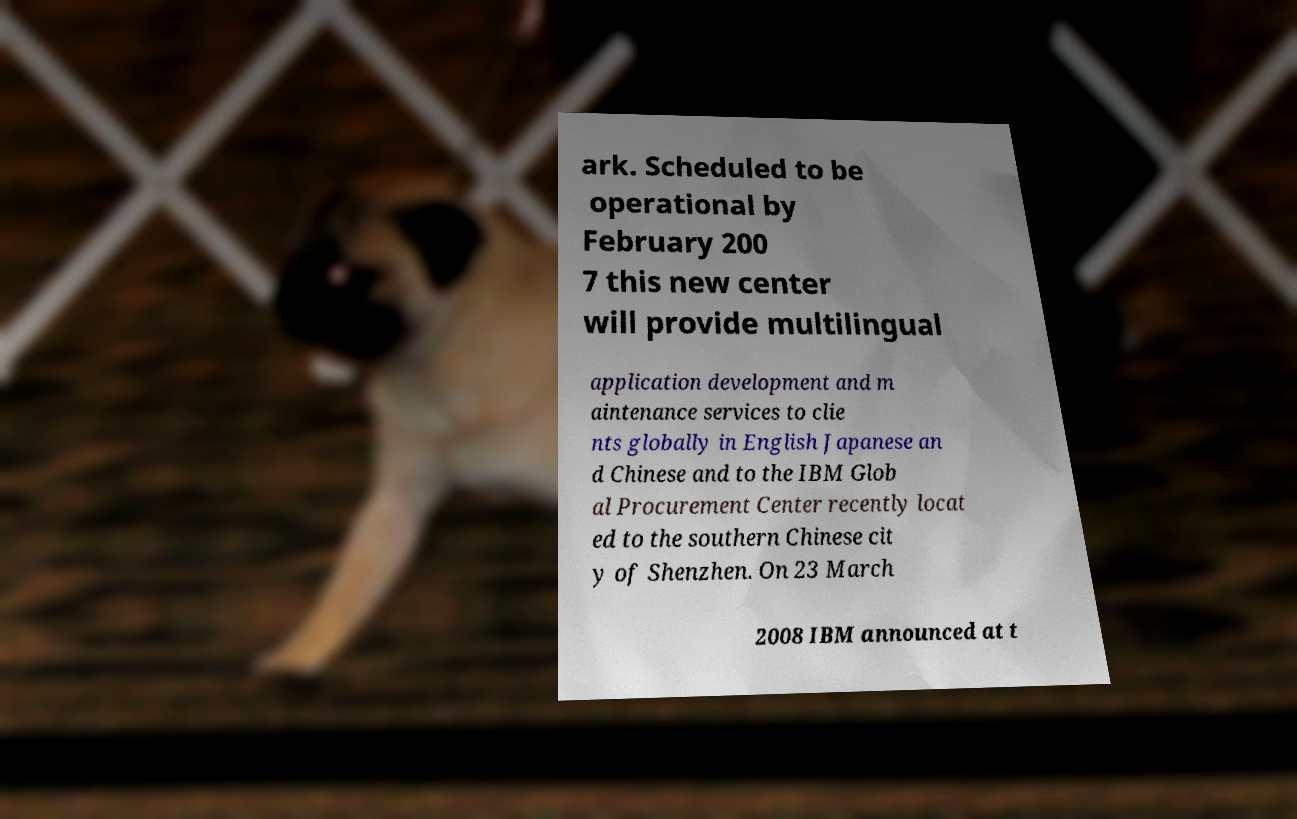Could you assist in decoding the text presented in this image and type it out clearly? ark. Scheduled to be operational by February 200 7 this new center will provide multilingual application development and m aintenance services to clie nts globally in English Japanese an d Chinese and to the IBM Glob al Procurement Center recently locat ed to the southern Chinese cit y of Shenzhen. On 23 March 2008 IBM announced at t 